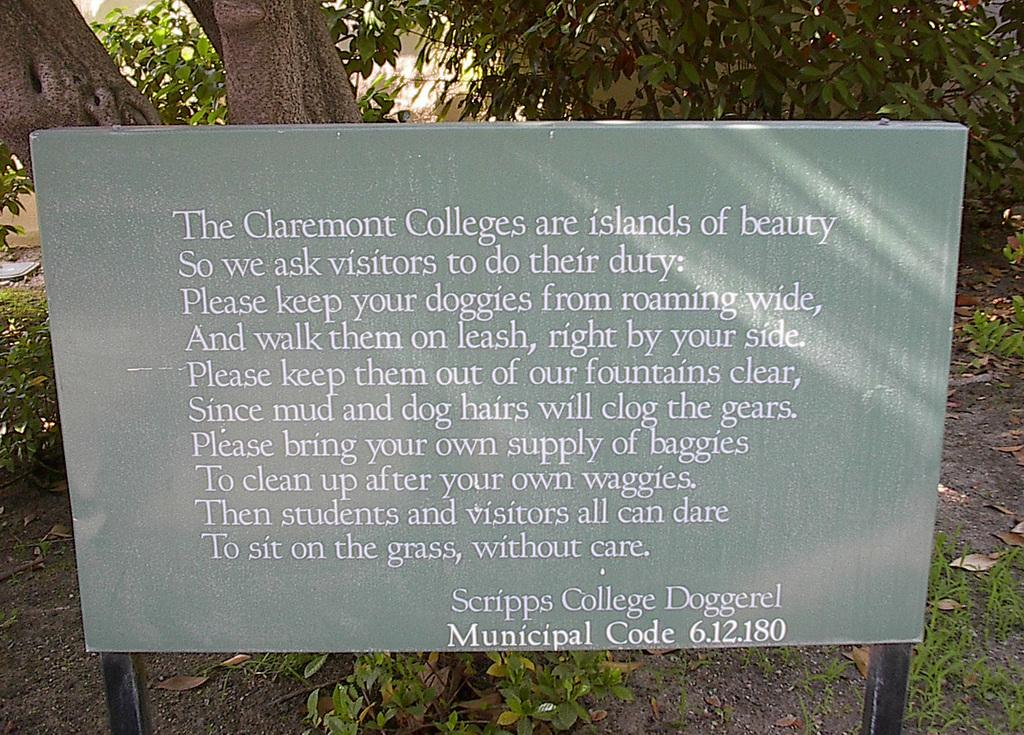What is on the board that is visible in the image? There is a board with text in the image. What can be seen in the background of the image? There are trees and houses in the background of the image. What type of paste is being used to stick the trees to the houses in the image? There is no paste or any indication of trees being stuck to houses in the image. 